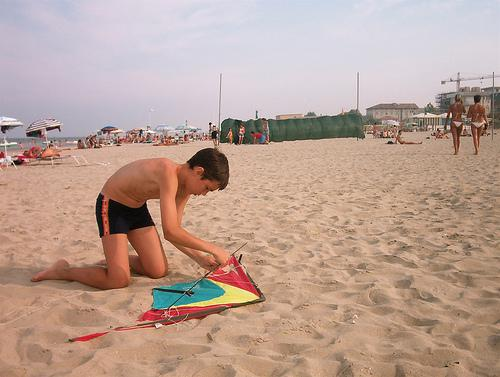Question: what is the boy doing?
Choices:
A. Playing.
B. Fixing a kite.
C. Throwing Frisbee.
D. Swimming.
Answer with the letter. Answer: B Question: where is the boy looking?
Choices:
A. Sky.
B. Down.
C. Sand.
D. Up.
Answer with the letter. Answer: B Question: who is the main subject of this image?
Choices:
A. Kite.
B. Beach.
C. A boy.
D. Sand pail.
Answer with the letter. Answer: C Question: where is the boy?
Choices:
A. Outside.
B. The ocean.
C. The beach.
D. River.
Answer with the letter. Answer: C Question: what is the boy interacting with?
Choices:
A. Frisbee.
B. A kite.
C. Dog.
D. Sand bucket.
Answer with the letter. Answer: B Question: what is the boy kneeling on?
Choices:
A. Ground.
B. Sand pail.
C. Grass.
D. Sand.
Answer with the letter. Answer: D 